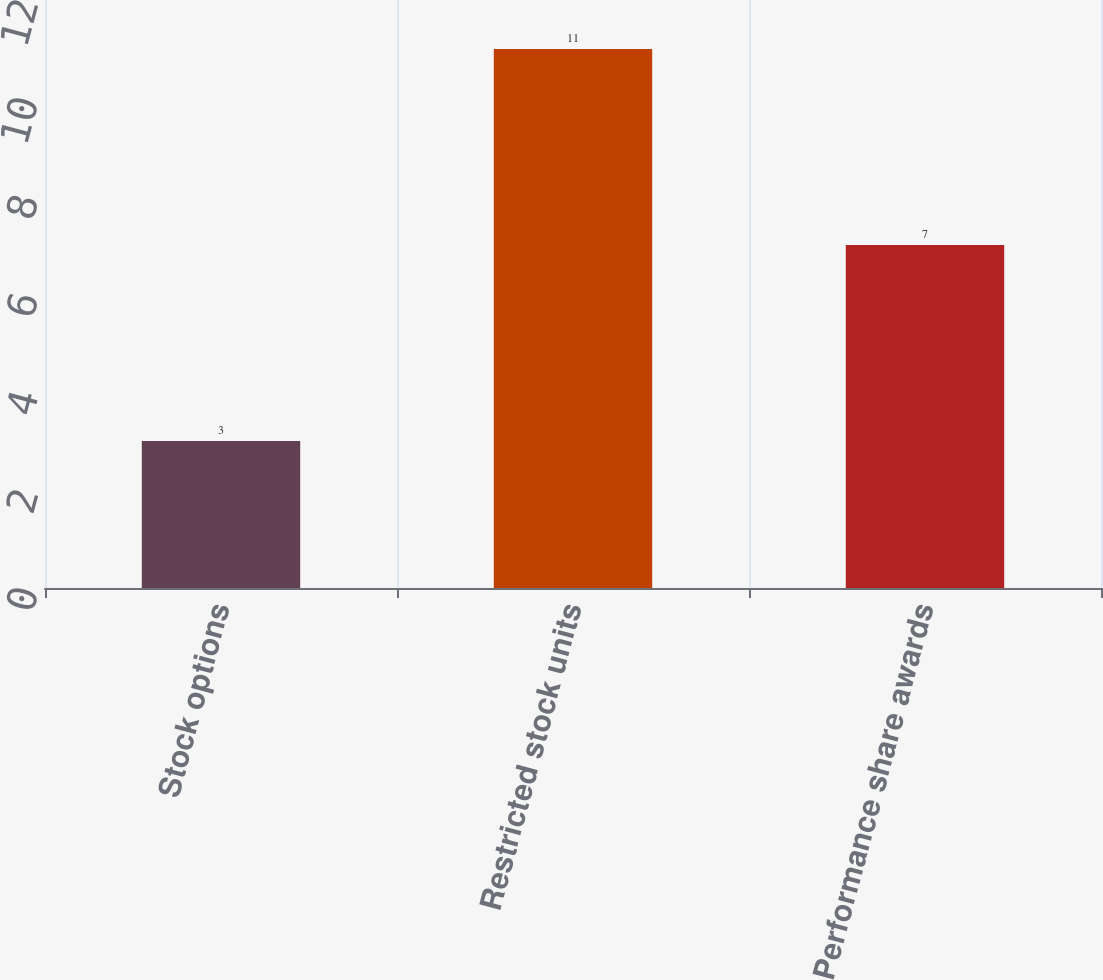Convert chart. <chart><loc_0><loc_0><loc_500><loc_500><bar_chart><fcel>Stock options<fcel>Restricted stock units<fcel>Performance share awards<nl><fcel>3<fcel>11<fcel>7<nl></chart> 